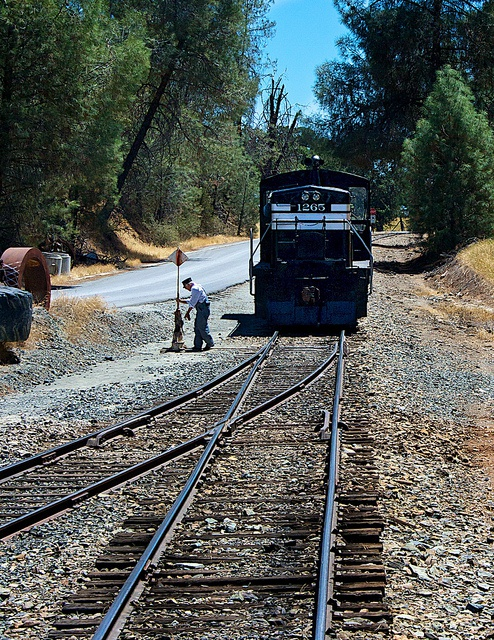Describe the objects in this image and their specific colors. I can see train in black, navy, lightblue, and blue tones and people in black, gray, lightgray, and navy tones in this image. 